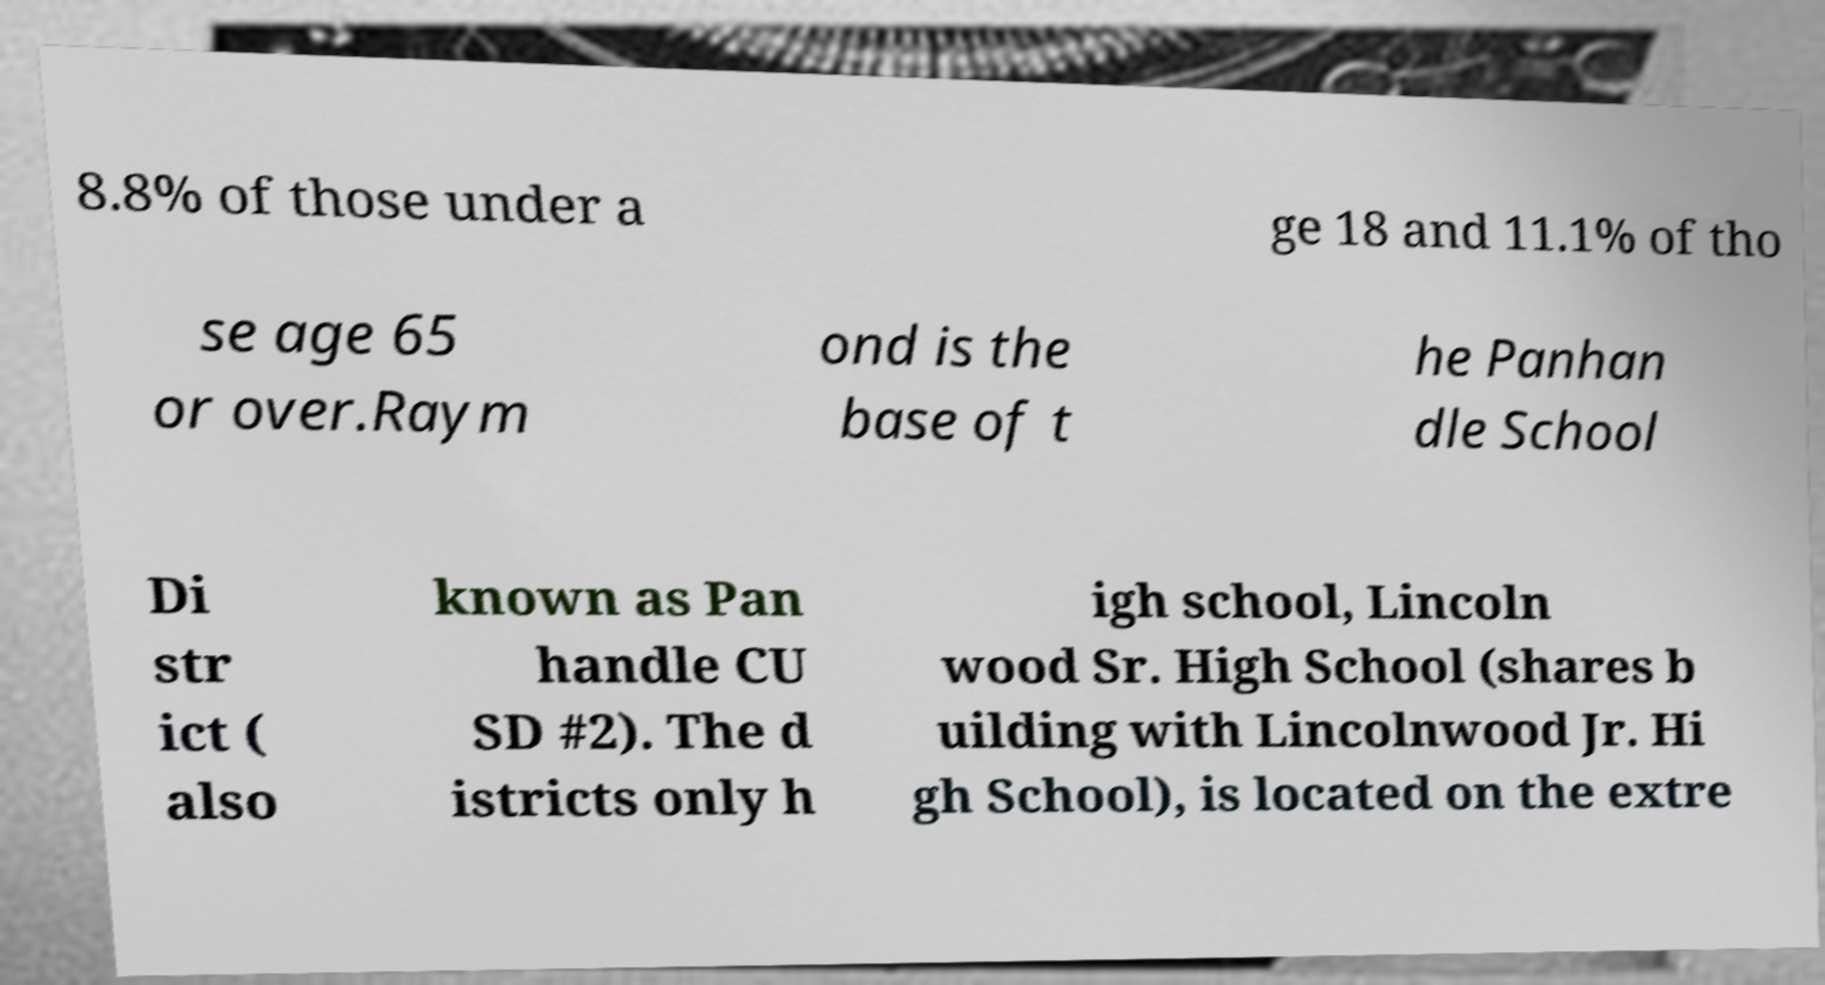Can you read and provide the text displayed in the image?This photo seems to have some interesting text. Can you extract and type it out for me? 8.8% of those under a ge 18 and 11.1% of tho se age 65 or over.Raym ond is the base of t he Panhan dle School Di str ict ( also known as Pan handle CU SD #2). The d istricts only h igh school, Lincoln wood Sr. High School (shares b uilding with Lincolnwood Jr. Hi gh School), is located on the extre 